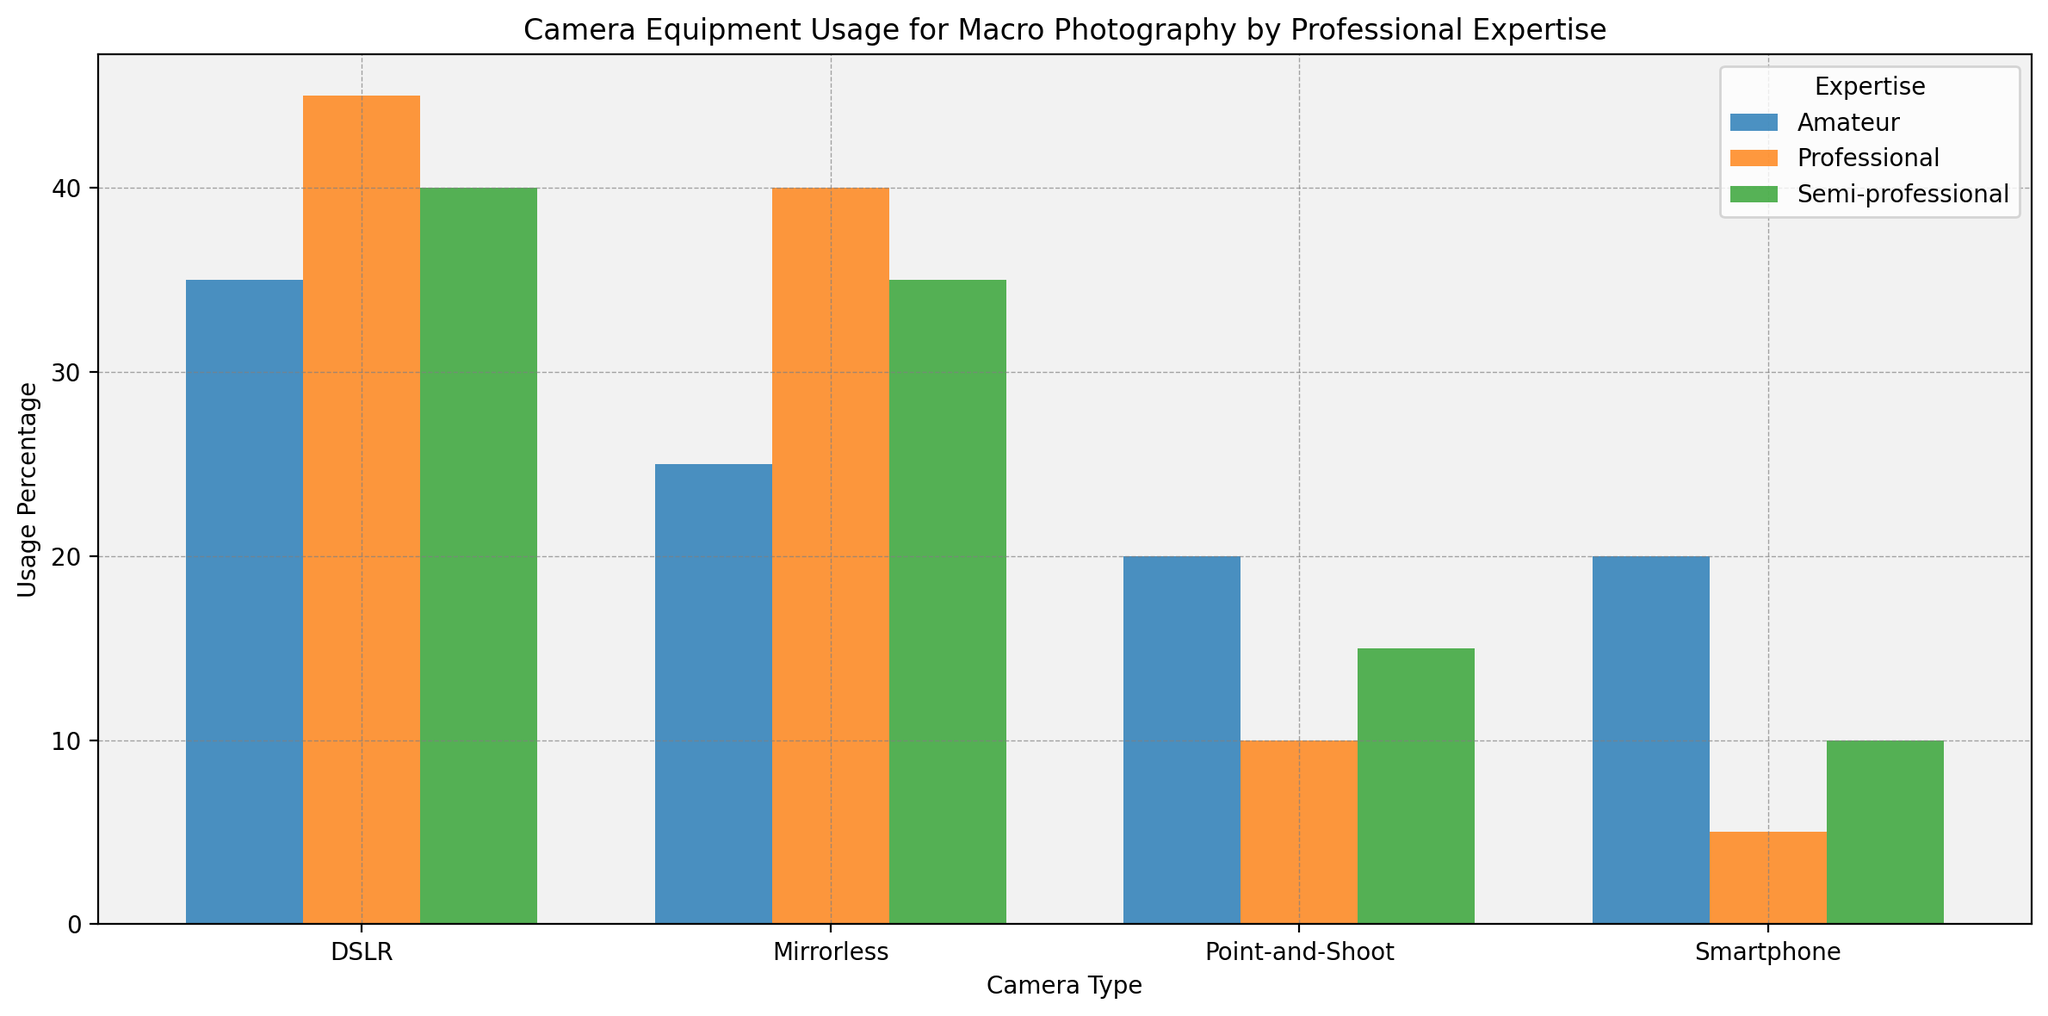What is the usage percentage of DSLR cameras by professionals? Look at the bar corresponding to "Professional" in the "DSLR" category.
Answer: 45 Which expertise group uses mirrorless cameras the most? Compare the heights of the bars for "Mirrorless" across all expertise groups. The "Professional" group has the highest bar.
Answer: Professional What is the difference in smartphone usage percentage between amateurs and professionals? Subtract the smartphone usage percentage of professionals (5%) from that of amateurs (20%).
Answer: 15 Which expertise group has the lowest usage percentage of point-and-shoot cameras? Compare the heights of the bars for "Point-and-Shoot" across all groups. The "Professional" group has the smallest bar.
Answer: Professional How does the usage of mirrorless cameras compare between amateurs and semi-professionals? Look at the "Mirrorless" category and compare the heights of the bars for "Amateur" (25%) and "Semi-professional" (35%).
Answer: Semi-professional uses more What is the total usage percentage of all camera types by semi-professionals? Sum the usage percentages for all camera types for the semi-professional group: DSLR (40%) + Mirrorless (35%) + Point-and-Shoot (15%) + Smartphone (10%) = 100%.
Answer: 100 On average, how much higher is the usage percentage of DSLRs compared to smartphones in all expertise groups? Calculate the difference in usage percentage of DSLRs and smartphones for each expertise group, then find the average. For amateurs: 35% - 20% = 15%, for semi-professionals: 40% - 10% = 30%, for professionals: 45% - 5% = 40%. Average = (15% + 30% + 40%) / 3 = 28.33%.
Answer: 28.33 Which group shows the most balanced usage across all camera types? A balanced usage would mean minimal differences between the usage percentages of different camera types. Compare the usage percentages across all camera types for each group. Amateurs: DSLR (35%), Mirrorless (25%), Point-and-Shoot (20%), Smartphone (20%) shows the most balance.
Answer: Amateur How does the usage of DSLRs vary across different expertise levels? Look at the "DSLR" category and compare the usage percentages across all expertise levels: Amateur (35%), Semi-professional (40%), Professional (45%).
Answer: Increases from amateur to professional What is the combined usage percentage for mirrorless and DSLR cameras by professionals? Add the usage percentages of mirrorless and DSLR cameras for the professional group: Mirrorless (40%) + DSLR (45%) = 85%.
Answer: 85 